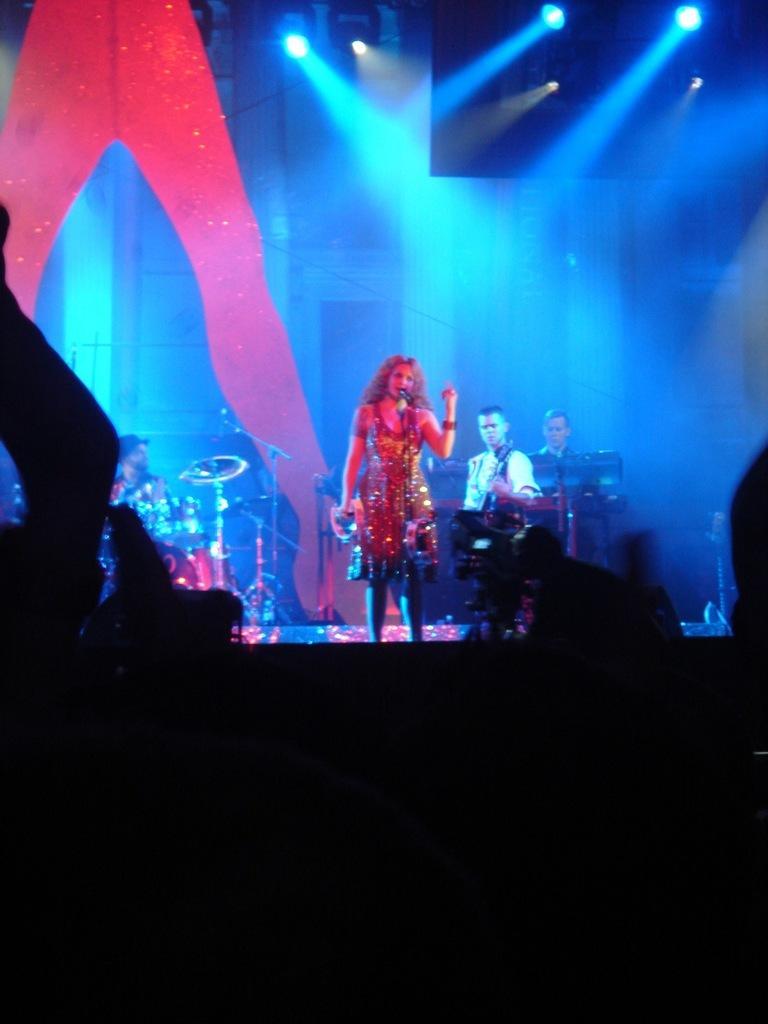How would you summarize this image in a sentence or two? In this image I can see few people and in the front of them I can see few musical instruments and few mics. I can also see number of lights on the top side of this image. 